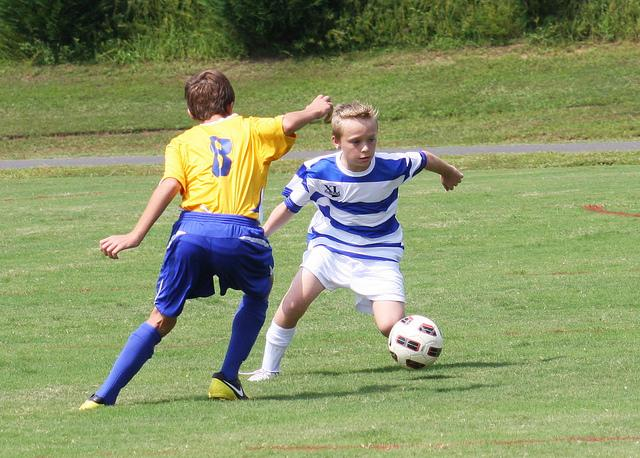What is the boy in blue and white trying to do? kick ball 